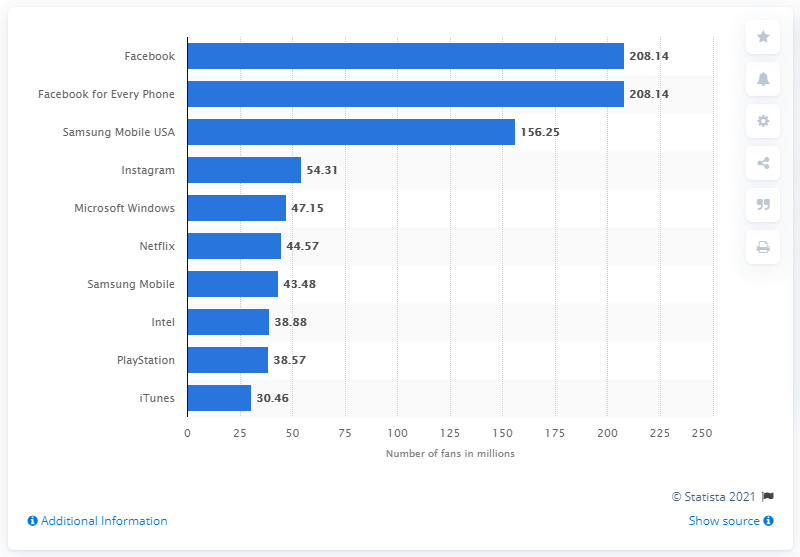Highlight a few significant elements in this photo. In April 2018, Sony's PlayStation brand had 38,880 fans on Facebook. In April 2018, Facebook was the most popular technology brand. 